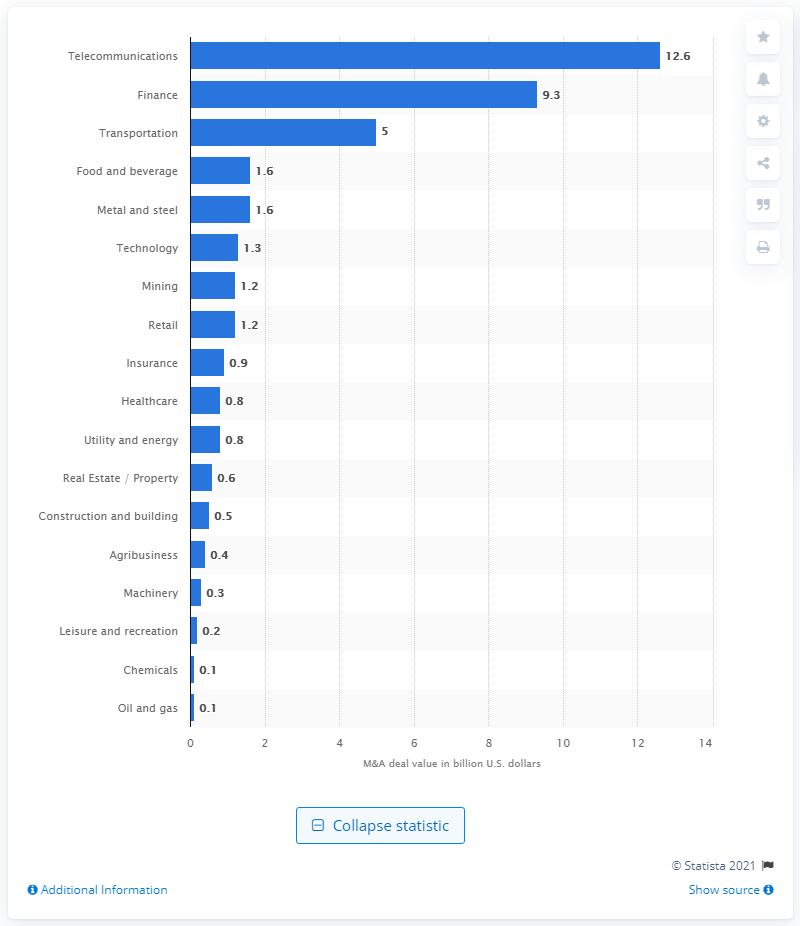Indicate a few pertinent items in this graphic. During the period between 2005 and 2015, the telecommunications industry received a total of $12.6 billion through merger and acquisition activities. 